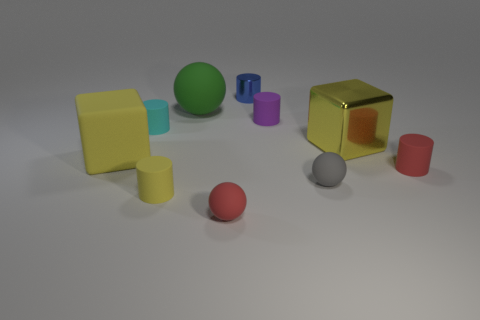How many other things are made of the same material as the small yellow cylinder?
Your response must be concise. 7. The cyan object that is the same shape as the tiny blue metal thing is what size?
Offer a terse response. Small. What is the large yellow block to the right of the big yellow rubber cube that is in front of the metallic thing to the left of the purple cylinder made of?
Provide a short and direct response. Metal. Are any blue cylinders visible?
Offer a very short reply. Yes. Is the color of the tiny shiny cylinder the same as the big thing that is on the right side of the large rubber sphere?
Provide a succinct answer. No. What is the color of the large ball?
Your answer should be compact. Green. Is there any other thing that has the same shape as the purple thing?
Give a very brief answer. Yes. What color is the other tiny metal thing that is the same shape as the purple object?
Give a very brief answer. Blue. Do the small blue object and the small purple thing have the same shape?
Keep it short and to the point. Yes. How many cubes are cyan rubber objects or rubber things?
Make the answer very short. 1. 